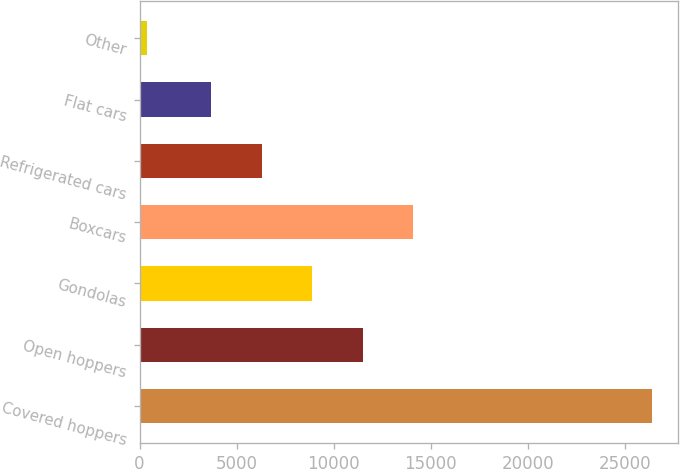Convert chart to OTSL. <chart><loc_0><loc_0><loc_500><loc_500><bar_chart><fcel>Covered hoppers<fcel>Open hoppers<fcel>Gondolas<fcel>Boxcars<fcel>Refrigerated cars<fcel>Flat cars<fcel>Other<nl><fcel>26433<fcel>11501.6<fcel>8894.4<fcel>14108.8<fcel>6287.2<fcel>3680<fcel>361<nl></chart> 